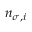<formula> <loc_0><loc_0><loc_500><loc_500>n _ { \sigma , i }</formula> 